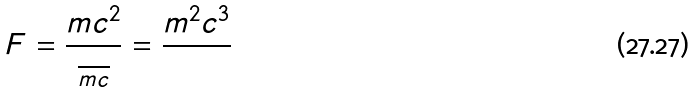<formula> <loc_0><loc_0><loc_500><loc_500>F = \frac { m c ^ { 2 } } { \frac { } { m c } } = \frac { m ^ { 2 } c ^ { 3 } } { }</formula> 